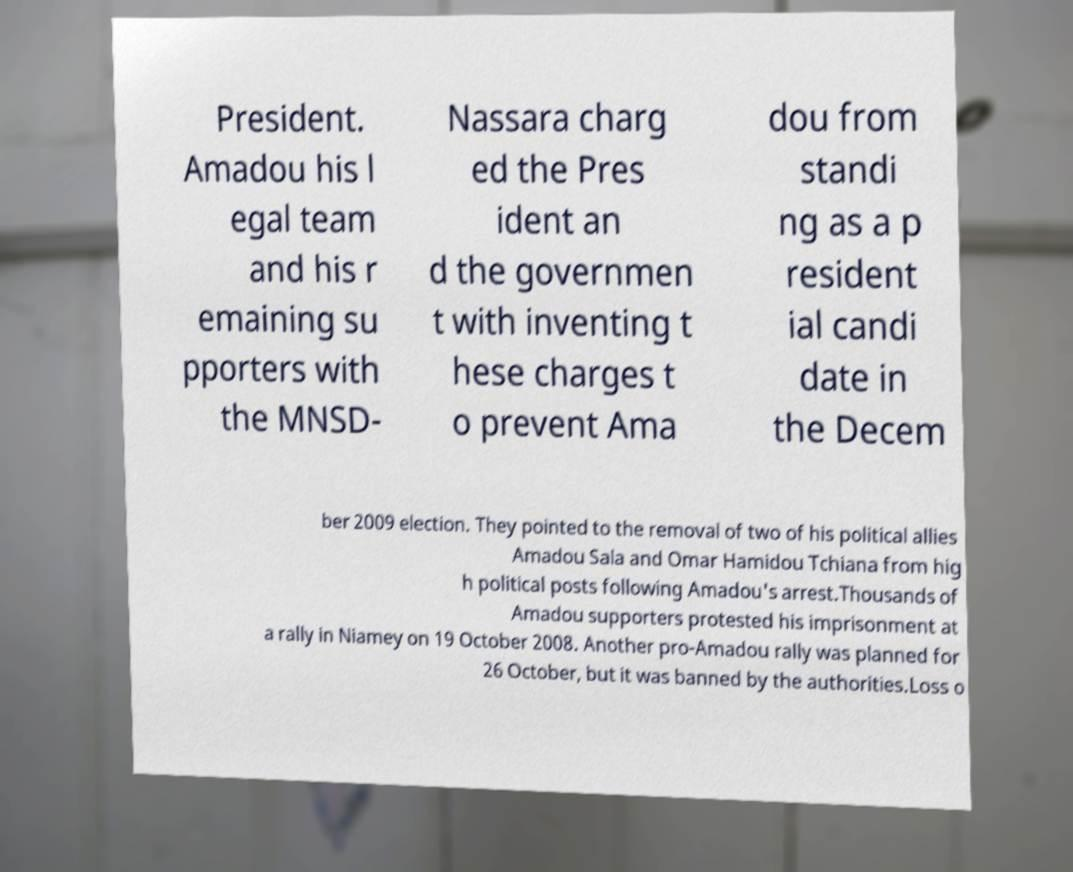Please read and relay the text visible in this image. What does it say? President. Amadou his l egal team and his r emaining su pporters with the MNSD- Nassara charg ed the Pres ident an d the governmen t with inventing t hese charges t o prevent Ama dou from standi ng as a p resident ial candi date in the Decem ber 2009 election. They pointed to the removal of two of his political allies Amadou Sala and Omar Hamidou Tchiana from hig h political posts following Amadou's arrest.Thousands of Amadou supporters protested his imprisonment at a rally in Niamey on 19 October 2008. Another pro-Amadou rally was planned for 26 October, but it was banned by the authorities.Loss o 